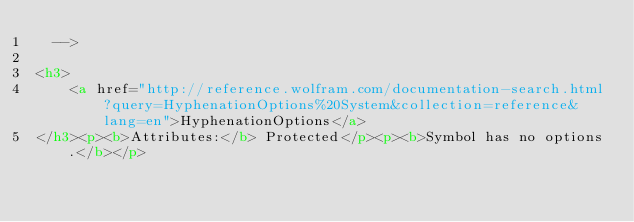Convert code to text. <code><loc_0><loc_0><loc_500><loc_500><_HTML_>  -->

<h3>
    <a href="http://reference.wolfram.com/documentation-search.html?query=HyphenationOptions%20System&collection=reference&lang=en">HyphenationOptions</a>
</h3><p><b>Attributes:</b> Protected</p><p><b>Symbol has no options.</b></p></code> 